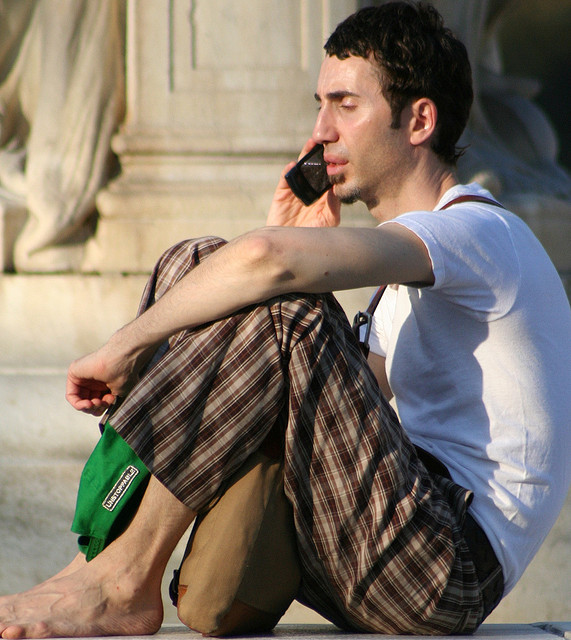<image>What shape is the medallion is the end of the man's necklace? I don't know what shape the medallion of the man's necklace is. There might be no medallion or it could be circle, square, or oval. What shape is the medallion is the end of the man's necklace? I don't know what shape the medallion is at the end of the man's necklace. It can be circle, square, round, oval or unknown. 